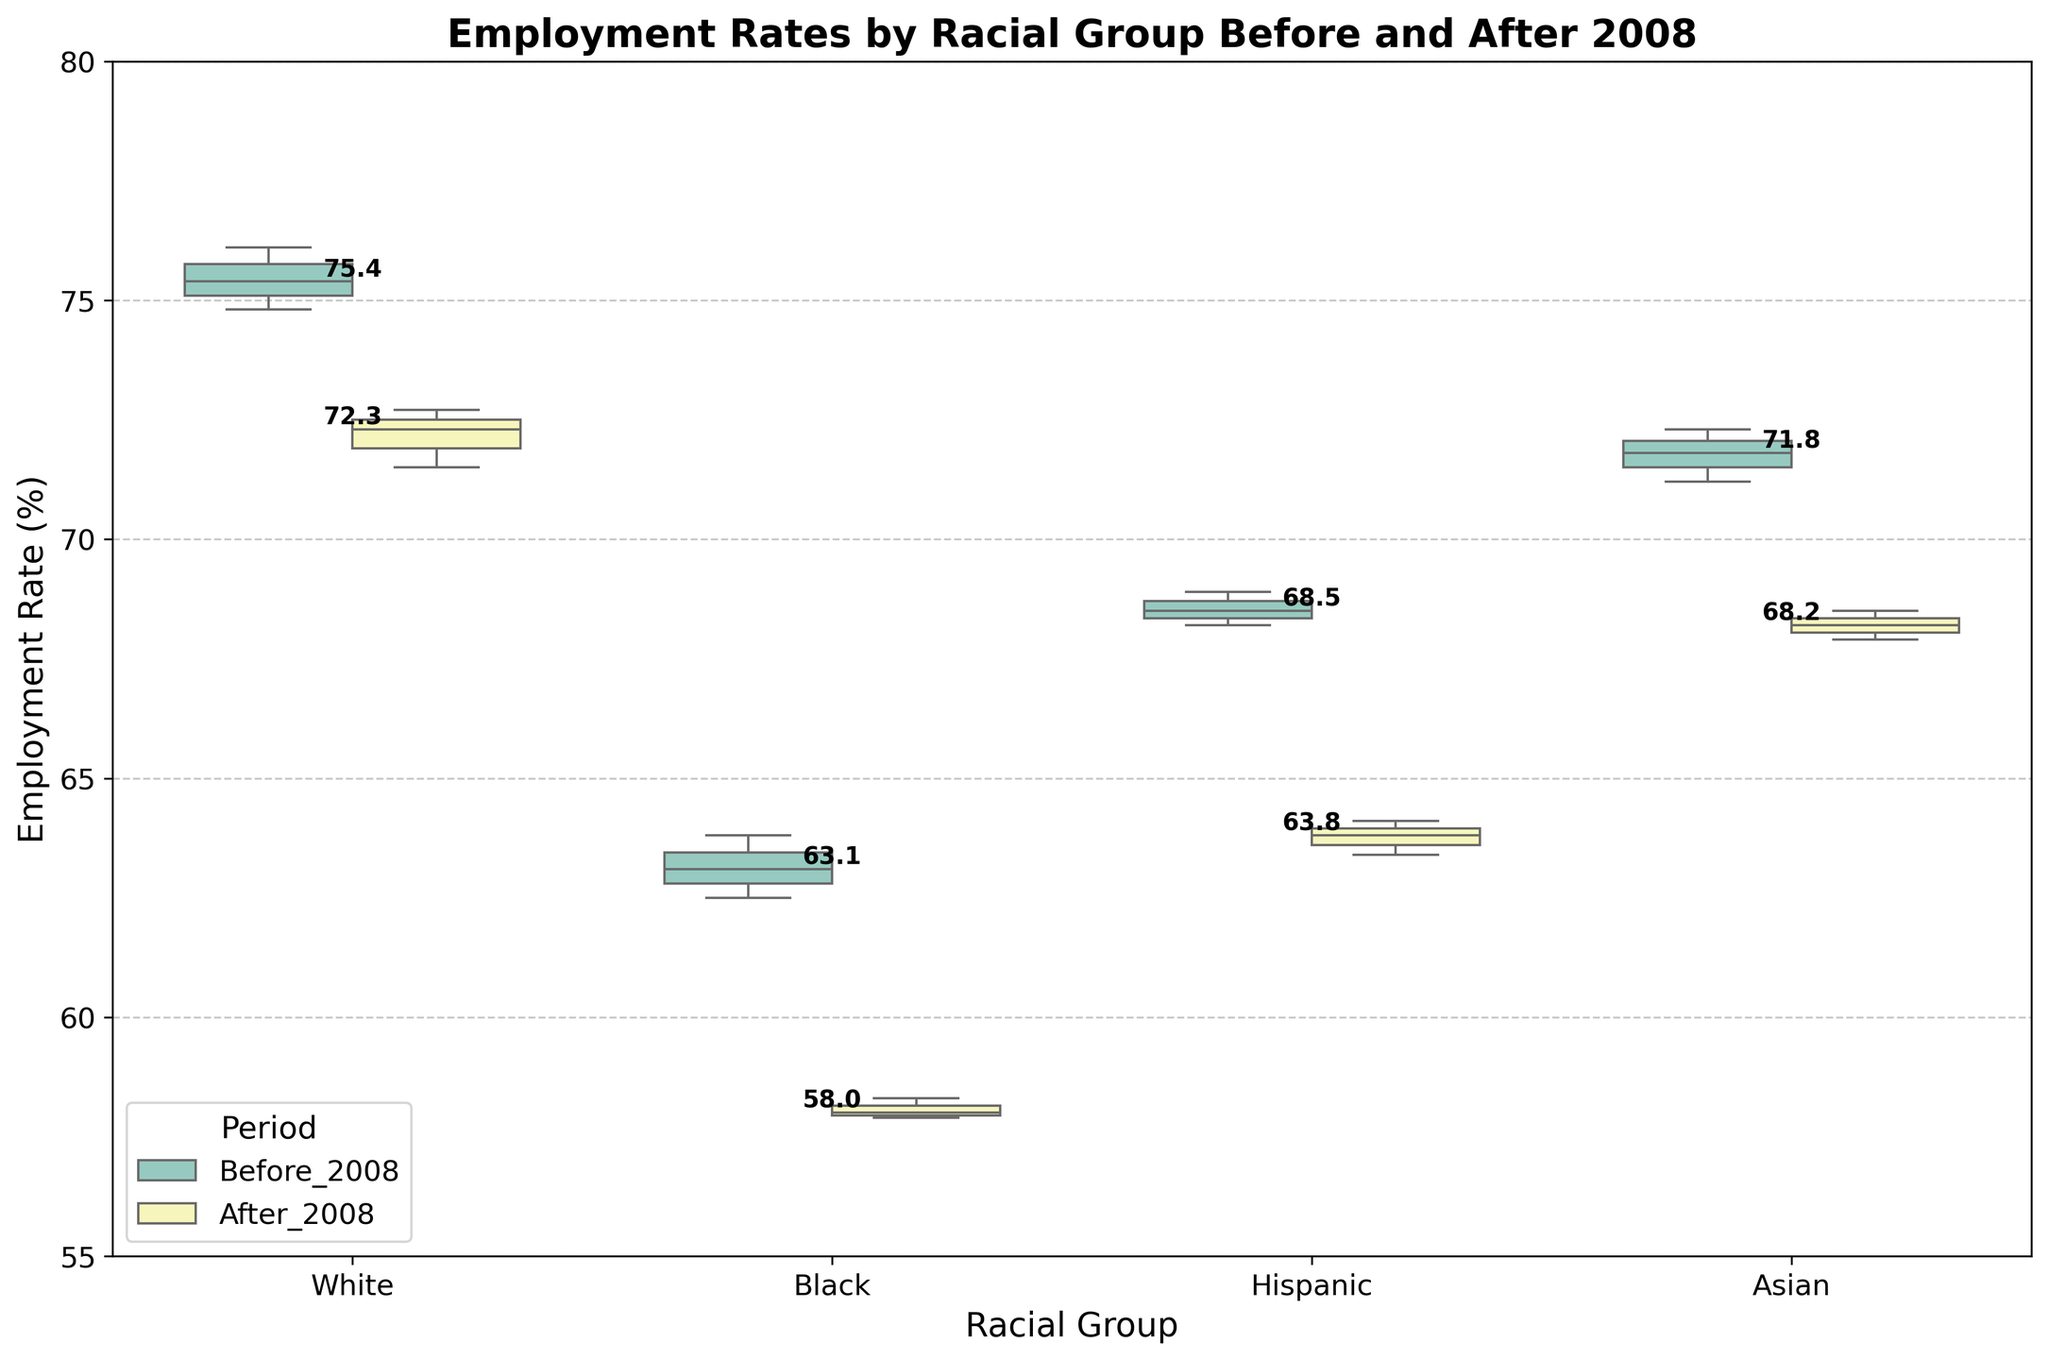What's the range of employment rates for the Black racial group before 2008? To find the range, we need to subtract the minimum employment rate from the maximum employment rate in the Black racial group before 2008. The minimum rate is 62.5, and the maximum is 63.8. Therefore, the range is 63.8 - 62.5.
Answer: 1.3 Which racial group experienced the largest drop in median employment rate after 2008? To determine which group had the largest drop, we compare the median employment rates before and after 2008 for each group. By examining the medians noted on the plot, find the largest numerical difference between the 'Before 2008' and 'After 2008' medians.
Answer: Black What's the median employment rate for Hispanic individuals after 2008? According to the values displayed above the boxes for the 'Hispanic' group during 'After 2008', the median value will be the central value which is often highlighted.
Answer: 63.8% How does the variability in employment rates compare between White and Black groups before 2008? Variability can be inferred from the sizes of the boxes (IQR) and the spread of the whiskers in the box plots. Compare these aspects for the White and Black racial groups before 2008 visually.
Answer: White has lower variability than Black Which racial group had the highest employment rate before 2008? Examine the positions of the top edges of the boxes for each racial group before 2008. The group with the highest position has the highest employment rate.
Answer: White What is the median drop in employment rate for the Asian group after 2008? To find the median drop for the Asian group, subtract the median employment rate after 2008 from the median rate before 2008. The medians are displayed on the plot for each period.
Answer: 3.2% Compare the employment rates of Hispanics before and after 2008. What is the difference in their medians? Look at the top of the boxes for the Hispanic group for both 'Before 2008' and 'After 2008' periods. Subtract the 'After 2008' median value from the 'Before 2008' median value.
Answer: 4.7% Which group has the smallest interquartile range (IQR) after 2008 and what does it imply? The IQR is represented by the width of the box. The group with the smallest height of the box after 2008 has the smallest IQR. Smaller IQR implies less variability in employment rates within that group.
Answer: White, less variability 